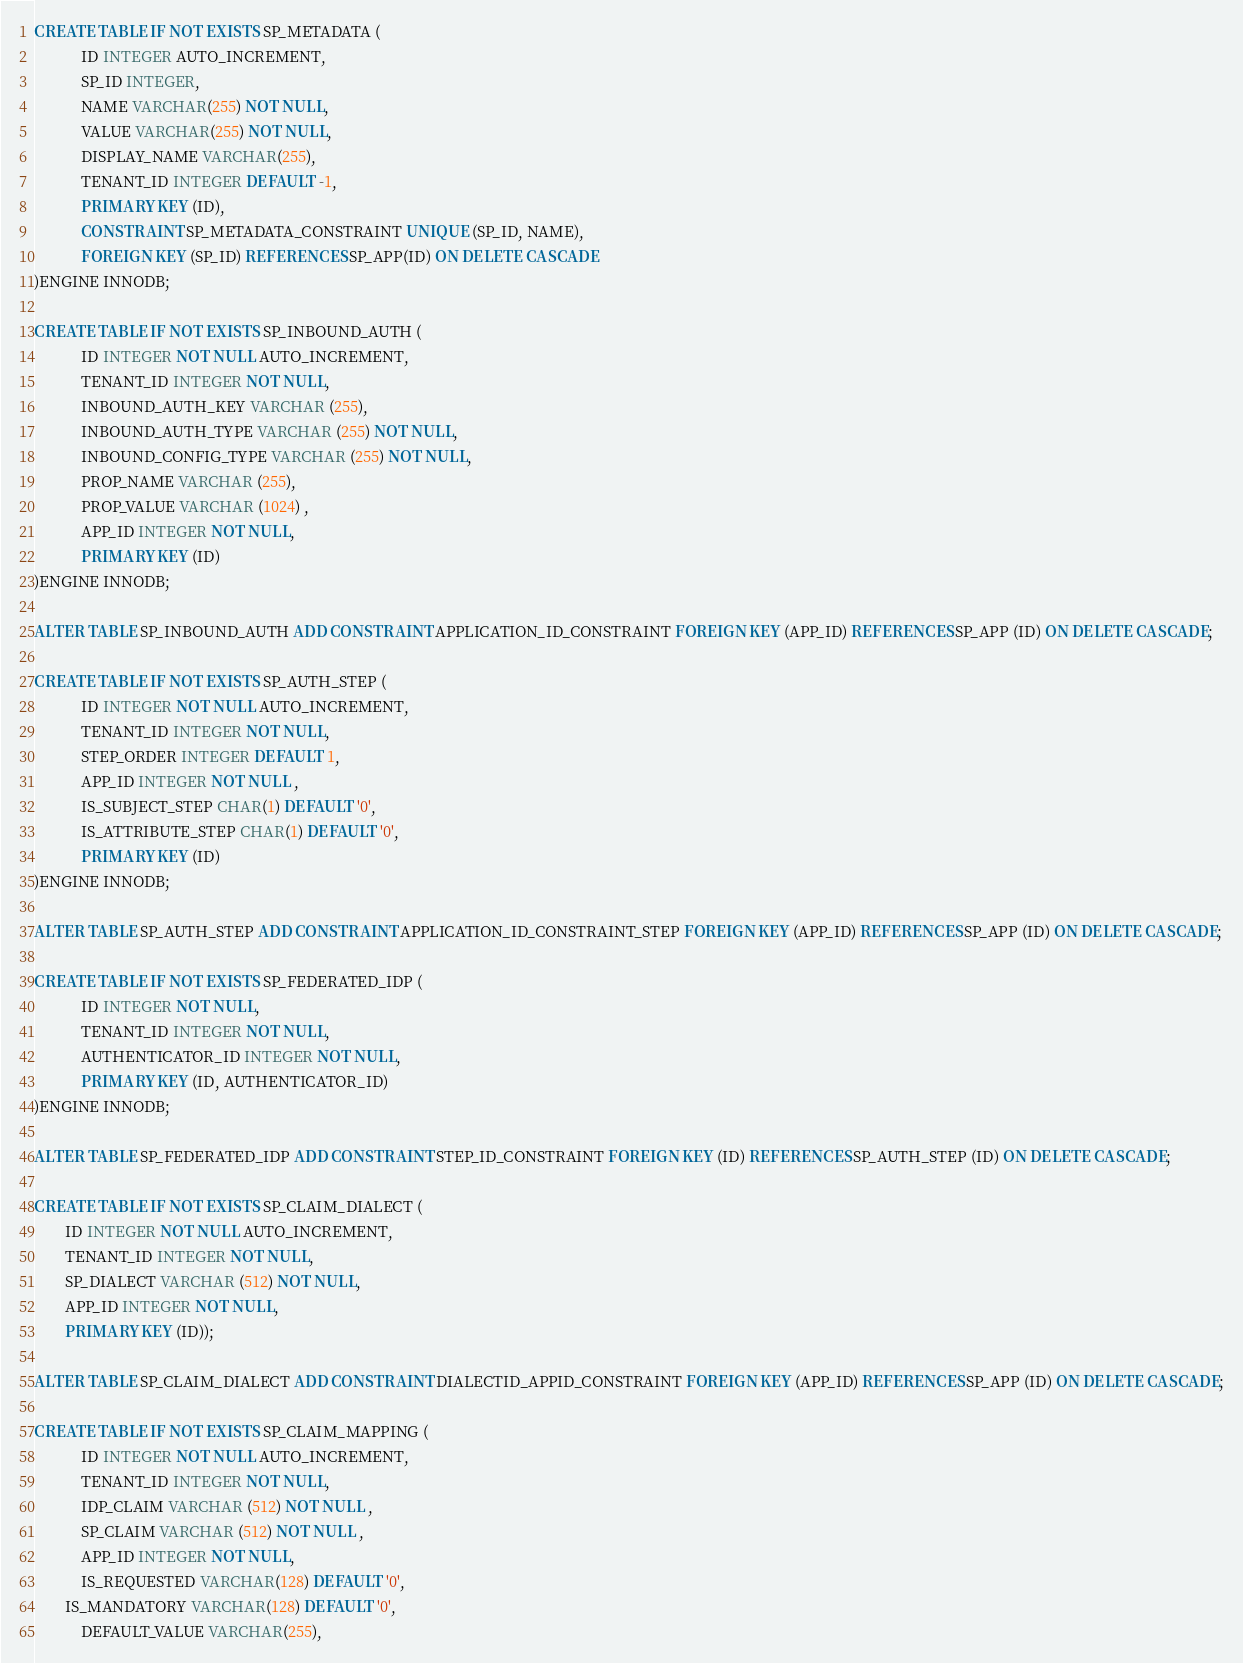<code> <loc_0><loc_0><loc_500><loc_500><_SQL_>CREATE TABLE IF NOT EXISTS SP_METADATA (
            ID INTEGER AUTO_INCREMENT,
            SP_ID INTEGER,
            NAME VARCHAR(255) NOT NULL,
            VALUE VARCHAR(255) NOT NULL,
            DISPLAY_NAME VARCHAR(255),
            TENANT_ID INTEGER DEFAULT -1,
            PRIMARY KEY (ID),
            CONSTRAINT SP_METADATA_CONSTRAINT UNIQUE (SP_ID, NAME),
            FOREIGN KEY (SP_ID) REFERENCES SP_APP(ID) ON DELETE CASCADE
)ENGINE INNODB;

CREATE TABLE IF NOT EXISTS SP_INBOUND_AUTH (
            ID INTEGER NOT NULL AUTO_INCREMENT,
            TENANT_ID INTEGER NOT NULL,
            INBOUND_AUTH_KEY VARCHAR (255),
            INBOUND_AUTH_TYPE VARCHAR (255) NOT NULL,
            INBOUND_CONFIG_TYPE VARCHAR (255) NOT NULL,
            PROP_NAME VARCHAR (255),
            PROP_VALUE VARCHAR (1024) ,
            APP_ID INTEGER NOT NULL,
            PRIMARY KEY (ID)
)ENGINE INNODB;

ALTER TABLE SP_INBOUND_AUTH ADD CONSTRAINT APPLICATION_ID_CONSTRAINT FOREIGN KEY (APP_ID) REFERENCES SP_APP (ID) ON DELETE CASCADE;

CREATE TABLE IF NOT EXISTS SP_AUTH_STEP (
            ID INTEGER NOT NULL AUTO_INCREMENT,
            TENANT_ID INTEGER NOT NULL,
            STEP_ORDER INTEGER DEFAULT 1,
            APP_ID INTEGER NOT NULL ,
            IS_SUBJECT_STEP CHAR(1) DEFAULT '0',
            IS_ATTRIBUTE_STEP CHAR(1) DEFAULT '0',
            PRIMARY KEY (ID)
)ENGINE INNODB;

ALTER TABLE SP_AUTH_STEP ADD CONSTRAINT APPLICATION_ID_CONSTRAINT_STEP FOREIGN KEY (APP_ID) REFERENCES SP_APP (ID) ON DELETE CASCADE;

CREATE TABLE IF NOT EXISTS SP_FEDERATED_IDP (
            ID INTEGER NOT NULL,
            TENANT_ID INTEGER NOT NULL,
            AUTHENTICATOR_ID INTEGER NOT NULL,
            PRIMARY KEY (ID, AUTHENTICATOR_ID)
)ENGINE INNODB;

ALTER TABLE SP_FEDERATED_IDP ADD CONSTRAINT STEP_ID_CONSTRAINT FOREIGN KEY (ID) REFERENCES SP_AUTH_STEP (ID) ON DELETE CASCADE;

CREATE TABLE IF NOT EXISTS SP_CLAIM_DIALECT (
	   	ID INTEGER NOT NULL AUTO_INCREMENT,
	   	TENANT_ID INTEGER NOT NULL,
	   	SP_DIALECT VARCHAR (512) NOT NULL,
	   	APP_ID INTEGER NOT NULL,
	   	PRIMARY KEY (ID));

ALTER TABLE SP_CLAIM_DIALECT ADD CONSTRAINT DIALECTID_APPID_CONSTRAINT FOREIGN KEY (APP_ID) REFERENCES SP_APP (ID) ON DELETE CASCADE;

CREATE TABLE IF NOT EXISTS SP_CLAIM_MAPPING (
            ID INTEGER NOT NULL AUTO_INCREMENT,
            TENANT_ID INTEGER NOT NULL,
            IDP_CLAIM VARCHAR (512) NOT NULL ,
            SP_CLAIM VARCHAR (512) NOT NULL ,
            APP_ID INTEGER NOT NULL,
            IS_REQUESTED VARCHAR(128) DEFAULT '0',
	    IS_MANDATORY VARCHAR(128) DEFAULT '0',
            DEFAULT_VALUE VARCHAR(255),</code> 